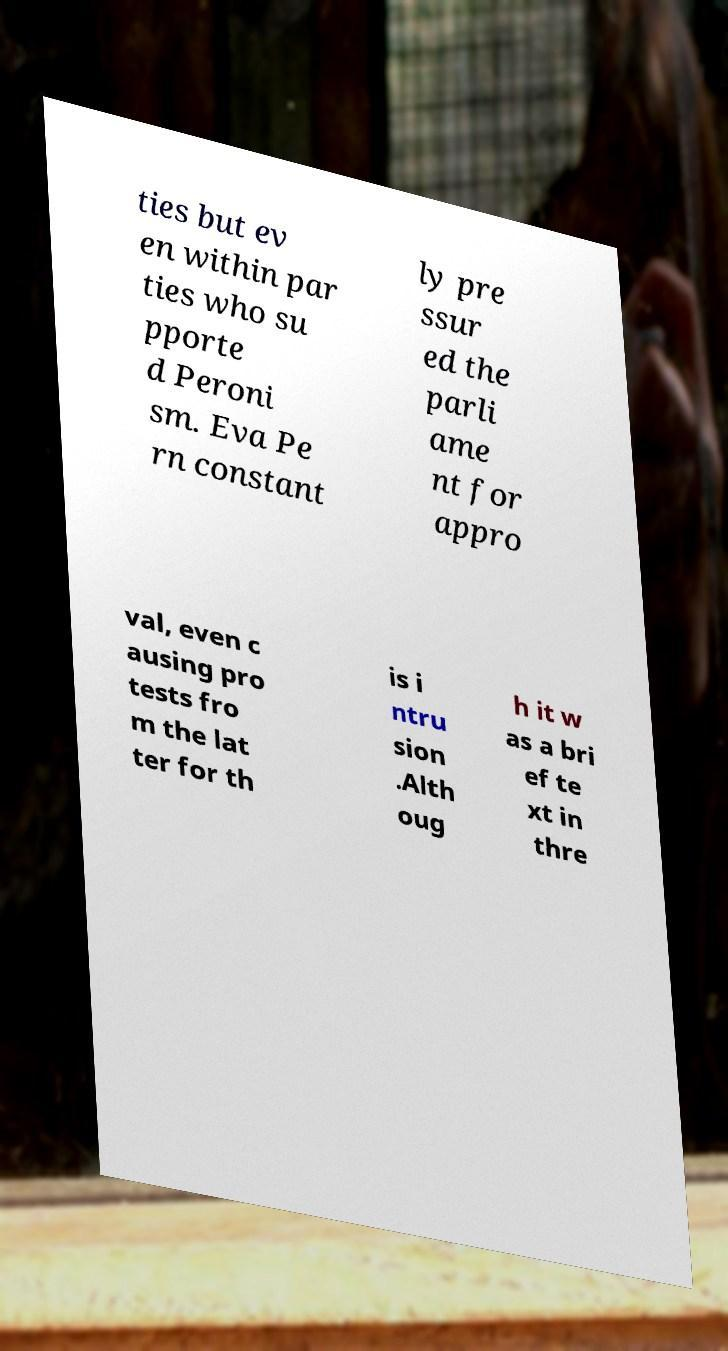Please identify and transcribe the text found in this image. ties but ev en within par ties who su pporte d Peroni sm. Eva Pe rn constant ly pre ssur ed the parli ame nt for appro val, even c ausing pro tests fro m the lat ter for th is i ntru sion .Alth oug h it w as a bri ef te xt in thre 